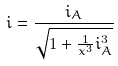<formula> <loc_0><loc_0><loc_500><loc_500>i = \frac { i _ { A } } { \sqrt { 1 + \frac { 1 } { x ^ { 3 } } i _ { A } ^ { 3 } } }</formula> 